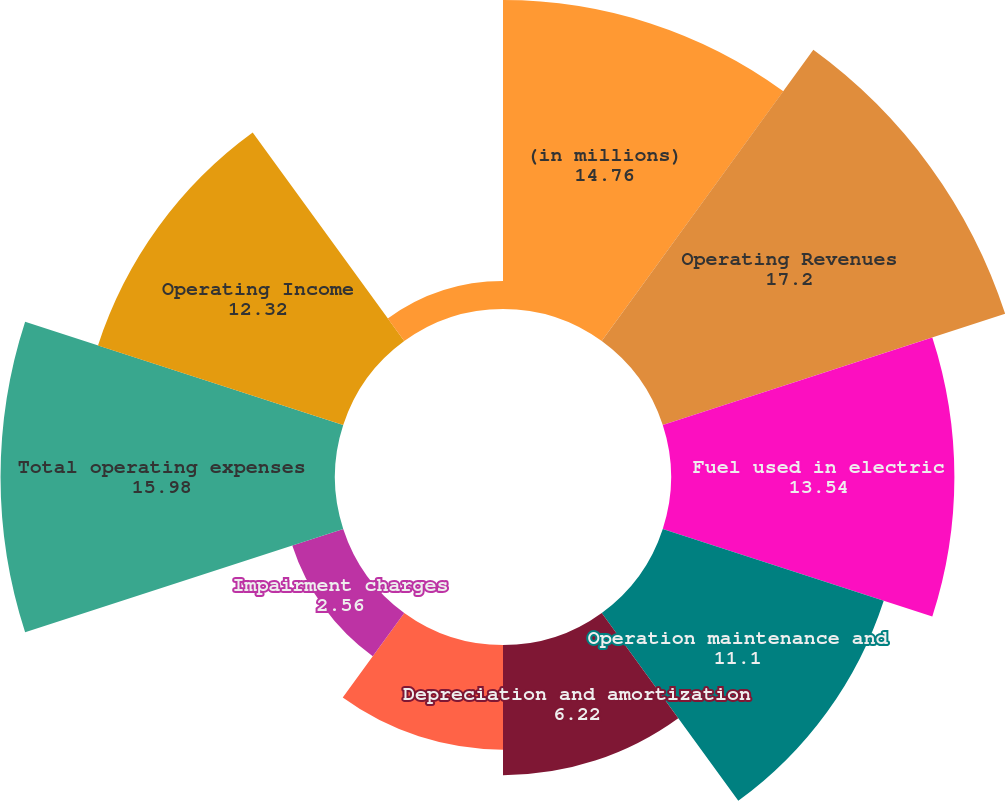Convert chart to OTSL. <chart><loc_0><loc_0><loc_500><loc_500><pie_chart><fcel>(in millions)<fcel>Operating Revenues<fcel>Fuel used in electric<fcel>Operation maintenance and<fcel>Depreciation and amortization<fcel>Property and other taxes<fcel>Impairment charges<fcel>Total operating expenses<fcel>Operating Income<fcel>Other Income and Expenses net<nl><fcel>14.76%<fcel>17.2%<fcel>13.54%<fcel>11.1%<fcel>6.22%<fcel>5.0%<fcel>2.56%<fcel>15.98%<fcel>12.32%<fcel>1.34%<nl></chart> 